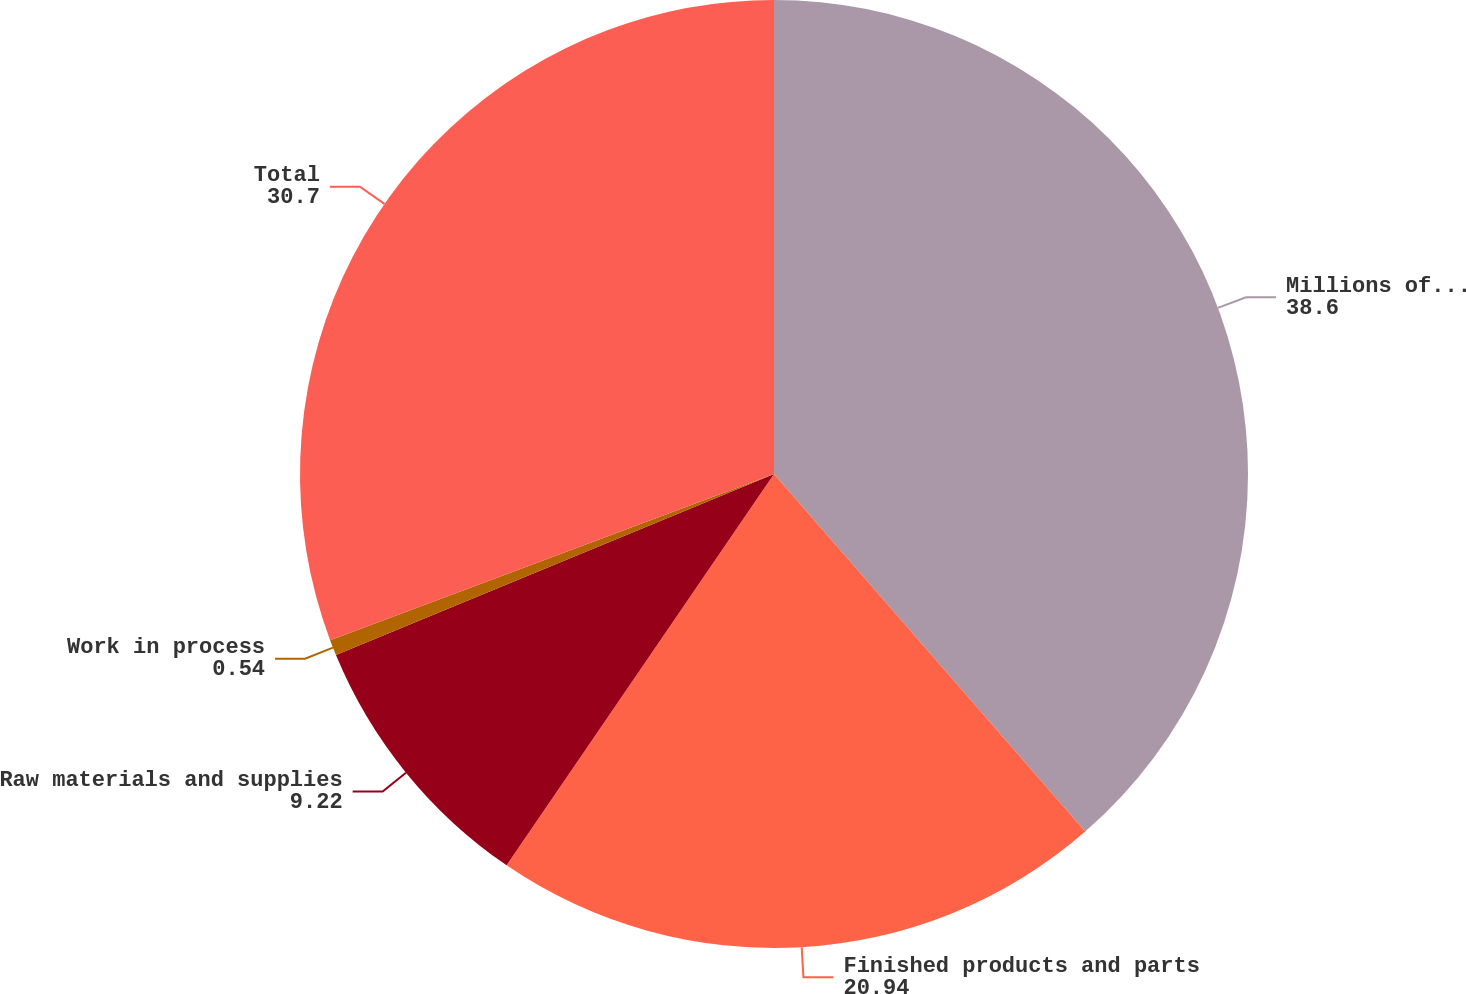<chart> <loc_0><loc_0><loc_500><loc_500><pie_chart><fcel>Millions of dollars<fcel>Finished products and parts<fcel>Raw materials and supplies<fcel>Work in process<fcel>Total<nl><fcel>38.6%<fcel>20.94%<fcel>9.22%<fcel>0.54%<fcel>30.7%<nl></chart> 